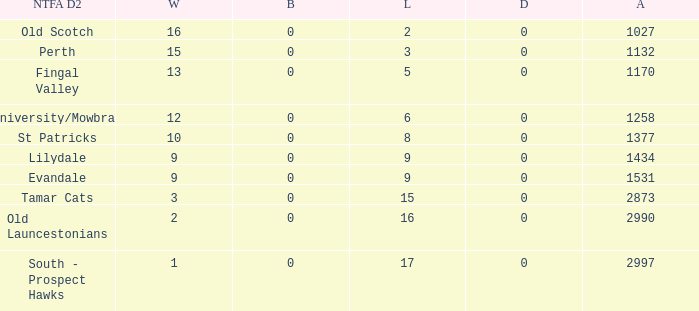What is the lowest number of draws of the NTFA Div 2 Lilydale? 0.0. 